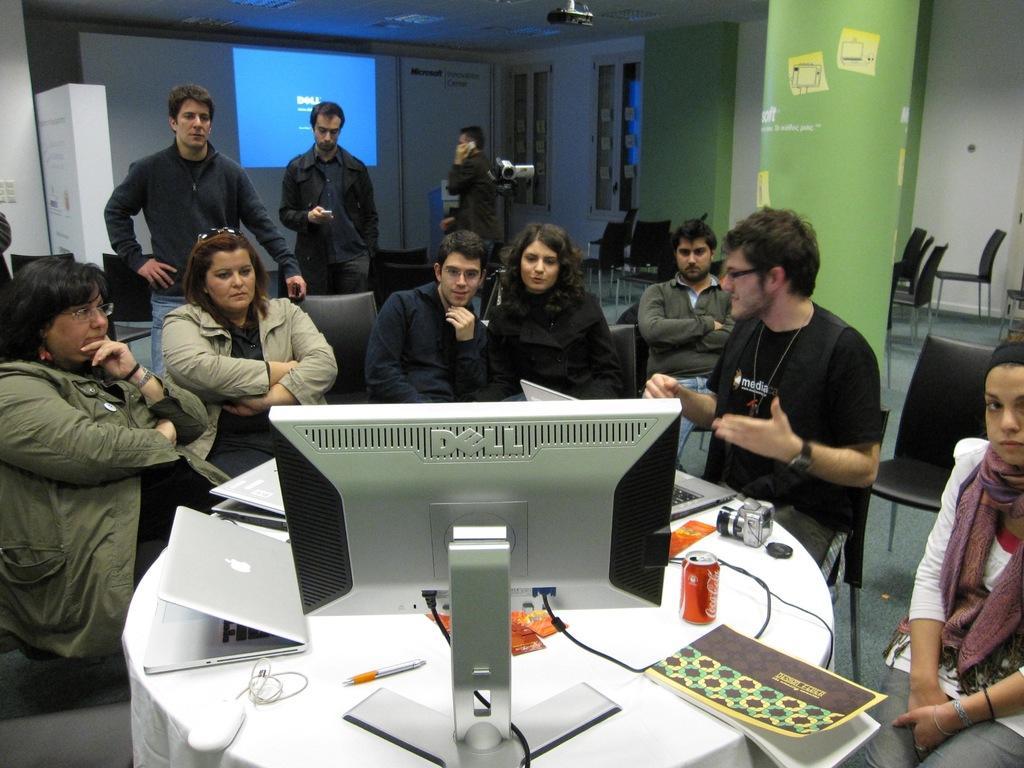Please provide a concise description of this image. At the bottom of the image there is a table, on the table there are some laptops and screen and tins and cameras, papers and pens and books. Behind the table few people are sitting and watching and few people are standing and there is a camera. At the top of the image there is wall, on the wall there is a screen and there are some windows. 